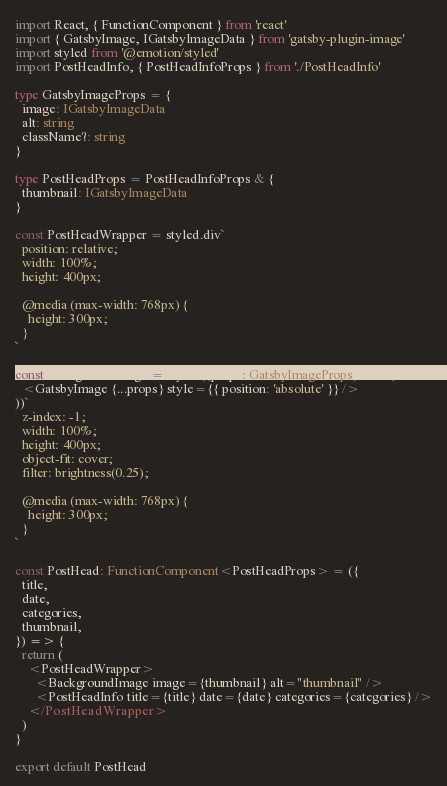Convert code to text. <code><loc_0><loc_0><loc_500><loc_500><_TypeScript_>import React, { FunctionComponent } from 'react'
import { GatsbyImage, IGatsbyImageData } from 'gatsby-plugin-image'
import styled from '@emotion/styled'
import PostHeadInfo, { PostHeadInfoProps } from './PostHeadInfo'

type GatsbyImageProps = {
  image: IGatsbyImageData
  alt: string
  className?: string
}

type PostHeadProps = PostHeadInfoProps & {
  thumbnail: IGatsbyImageData
}

const PostHeadWrapper = styled.div`
  position: relative;
  width: 100%;
  height: 400px;

  @media (max-width: 768px) {
    height: 300px;
  }
`

const BackgroundImage = styled((props: GatsbyImageProps) => (
  <GatsbyImage {...props} style={{ position: 'absolute' }} />
))`
  z-index: -1;
  width: 100%;
  height: 400px;
  object-fit: cover;
  filter: brightness(0.25);

  @media (max-width: 768px) {
    height: 300px;
  }
`

const PostHead: FunctionComponent<PostHeadProps> = ({
  title,
  date,
  categories,
  thumbnail,
}) => {
  return (
    <PostHeadWrapper>
      <BackgroundImage image={thumbnail} alt="thumbnail" />
      <PostHeadInfo title={title} date={date} categories={categories} />
    </PostHeadWrapper>
  )
}

export default PostHead
</code> 